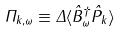Convert formula to latex. <formula><loc_0><loc_0><loc_500><loc_500>\Pi _ { k , \omega } \equiv \Delta \langle \hat { B } _ { \omega } ^ { \dagger } \hat { P } _ { k } \rangle</formula> 